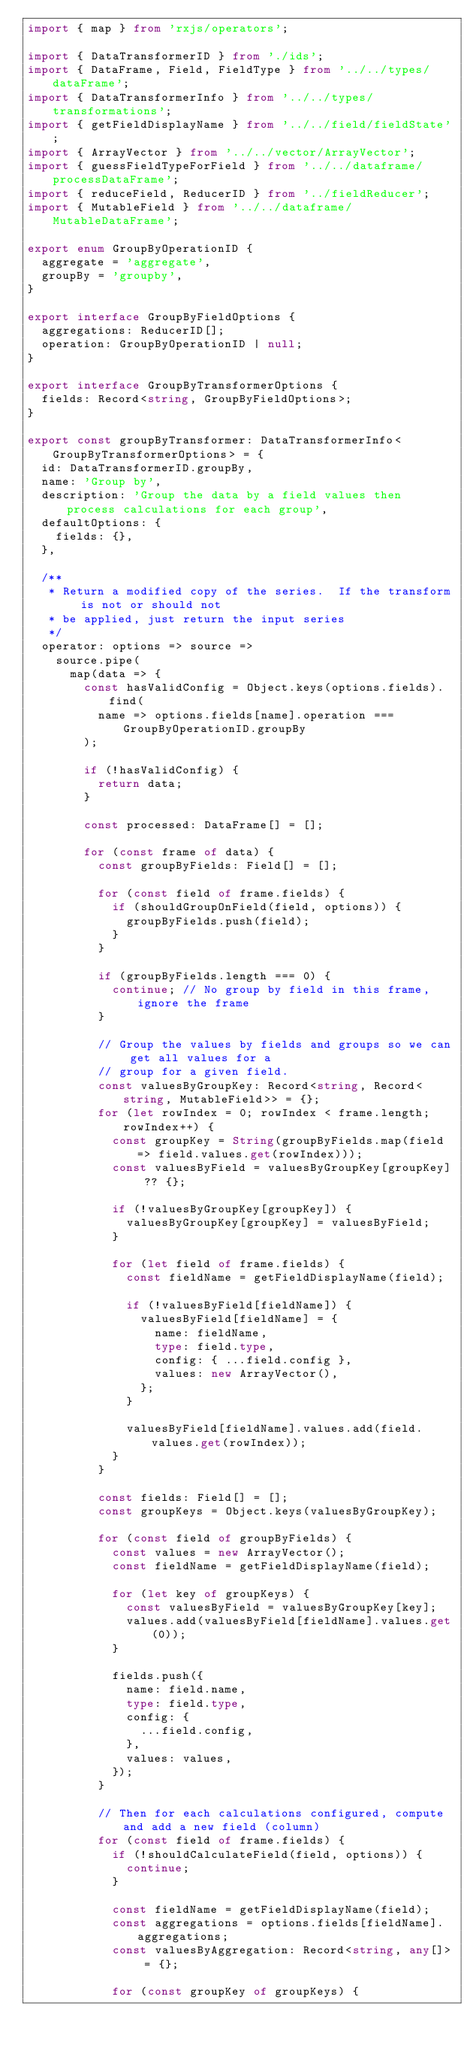<code> <loc_0><loc_0><loc_500><loc_500><_TypeScript_>import { map } from 'rxjs/operators';

import { DataTransformerID } from './ids';
import { DataFrame, Field, FieldType } from '../../types/dataFrame';
import { DataTransformerInfo } from '../../types/transformations';
import { getFieldDisplayName } from '../../field/fieldState';
import { ArrayVector } from '../../vector/ArrayVector';
import { guessFieldTypeForField } from '../../dataframe/processDataFrame';
import { reduceField, ReducerID } from '../fieldReducer';
import { MutableField } from '../../dataframe/MutableDataFrame';

export enum GroupByOperationID {
  aggregate = 'aggregate',
  groupBy = 'groupby',
}

export interface GroupByFieldOptions {
  aggregations: ReducerID[];
  operation: GroupByOperationID | null;
}

export interface GroupByTransformerOptions {
  fields: Record<string, GroupByFieldOptions>;
}

export const groupByTransformer: DataTransformerInfo<GroupByTransformerOptions> = {
  id: DataTransformerID.groupBy,
  name: 'Group by',
  description: 'Group the data by a field values then process calculations for each group',
  defaultOptions: {
    fields: {},
  },

  /**
   * Return a modified copy of the series.  If the transform is not or should not
   * be applied, just return the input series
   */
  operator: options => source =>
    source.pipe(
      map(data => {
        const hasValidConfig = Object.keys(options.fields).find(
          name => options.fields[name].operation === GroupByOperationID.groupBy
        );

        if (!hasValidConfig) {
          return data;
        }

        const processed: DataFrame[] = [];

        for (const frame of data) {
          const groupByFields: Field[] = [];

          for (const field of frame.fields) {
            if (shouldGroupOnField(field, options)) {
              groupByFields.push(field);
            }
          }

          if (groupByFields.length === 0) {
            continue; // No group by field in this frame, ignore the frame
          }

          // Group the values by fields and groups so we can get all values for a
          // group for a given field.
          const valuesByGroupKey: Record<string, Record<string, MutableField>> = {};
          for (let rowIndex = 0; rowIndex < frame.length; rowIndex++) {
            const groupKey = String(groupByFields.map(field => field.values.get(rowIndex)));
            const valuesByField = valuesByGroupKey[groupKey] ?? {};

            if (!valuesByGroupKey[groupKey]) {
              valuesByGroupKey[groupKey] = valuesByField;
            }

            for (let field of frame.fields) {
              const fieldName = getFieldDisplayName(field);

              if (!valuesByField[fieldName]) {
                valuesByField[fieldName] = {
                  name: fieldName,
                  type: field.type,
                  config: { ...field.config },
                  values: new ArrayVector(),
                };
              }

              valuesByField[fieldName].values.add(field.values.get(rowIndex));
            }
          }

          const fields: Field[] = [];
          const groupKeys = Object.keys(valuesByGroupKey);

          for (const field of groupByFields) {
            const values = new ArrayVector();
            const fieldName = getFieldDisplayName(field);

            for (let key of groupKeys) {
              const valuesByField = valuesByGroupKey[key];
              values.add(valuesByField[fieldName].values.get(0));
            }

            fields.push({
              name: field.name,
              type: field.type,
              config: {
                ...field.config,
              },
              values: values,
            });
          }

          // Then for each calculations configured, compute and add a new field (column)
          for (const field of frame.fields) {
            if (!shouldCalculateField(field, options)) {
              continue;
            }

            const fieldName = getFieldDisplayName(field);
            const aggregations = options.fields[fieldName].aggregations;
            const valuesByAggregation: Record<string, any[]> = {};

            for (const groupKey of groupKeys) {</code> 